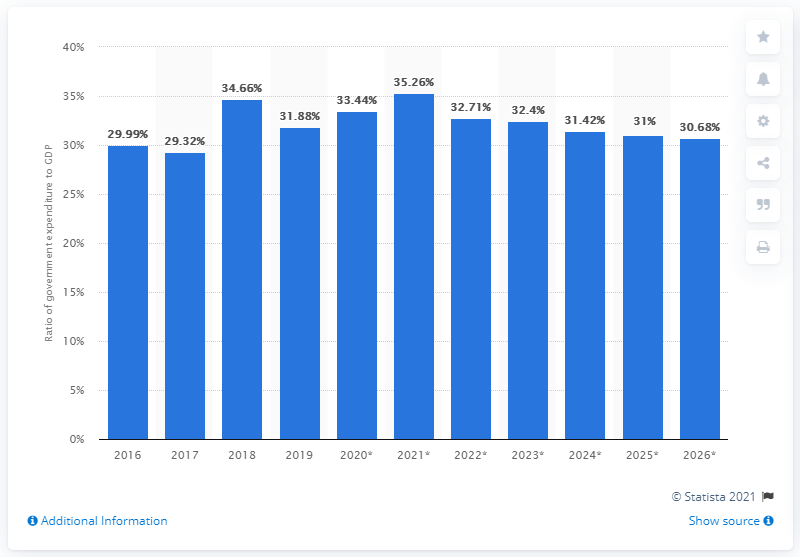Mention a couple of crucial points in this snapshot. In 2019, government expenditure accounted for 31.88% of Colombia's GDP. 